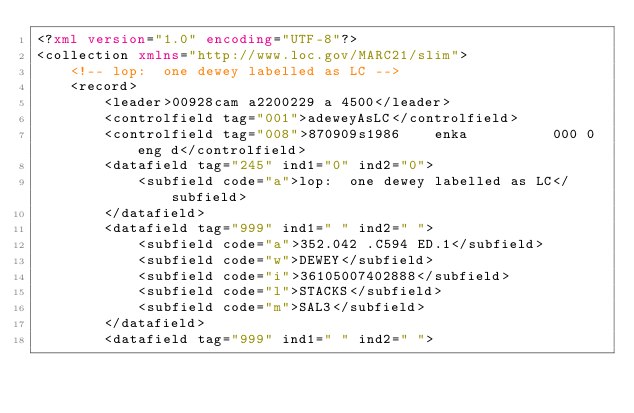Convert code to text. <code><loc_0><loc_0><loc_500><loc_500><_XML_><?xml version="1.0" encoding="UTF-8"?>
<collection xmlns="http://www.loc.gov/MARC21/slim">
    <!-- lop:  one dewey labelled as LC -->
    <record>
        <leader>00928cam a2200229 a 4500</leader>
        <controlfield tag="001">adeweyAsLC</controlfield>
        <controlfield tag="008">870909s1986    enka          000 0 eng d</controlfield>
        <datafield tag="245" ind1="0" ind2="0">
            <subfield code="a">lop:  one dewey labelled as LC</subfield>
        </datafield>
        <datafield tag="999" ind1=" " ind2=" ">
            <subfield code="a">352.042 .C594 ED.1</subfield>
            <subfield code="w">DEWEY</subfield>
            <subfield code="i">36105007402888</subfield>
            <subfield code="l">STACKS</subfield>
            <subfield code="m">SAL3</subfield>
        </datafield>    
        <datafield tag="999" ind1=" " ind2=" "></code> 